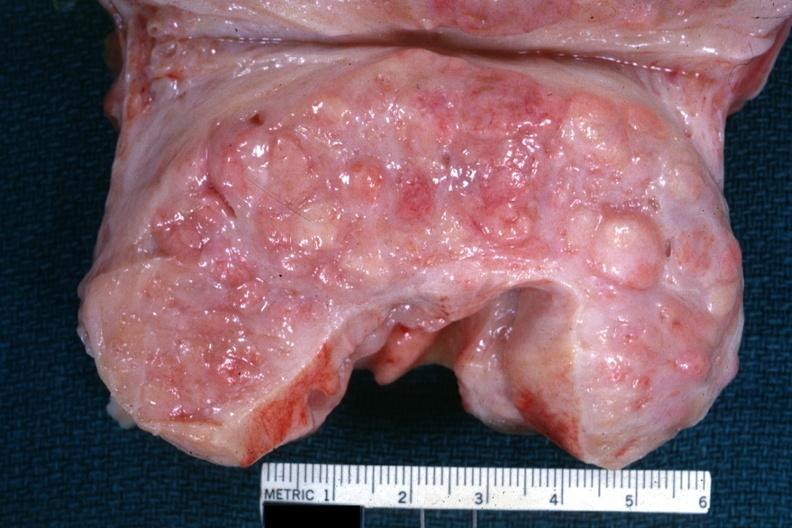does this image show excellent example cut surface with nodular hyperplasia?
Answer the question using a single word or phrase. Yes 